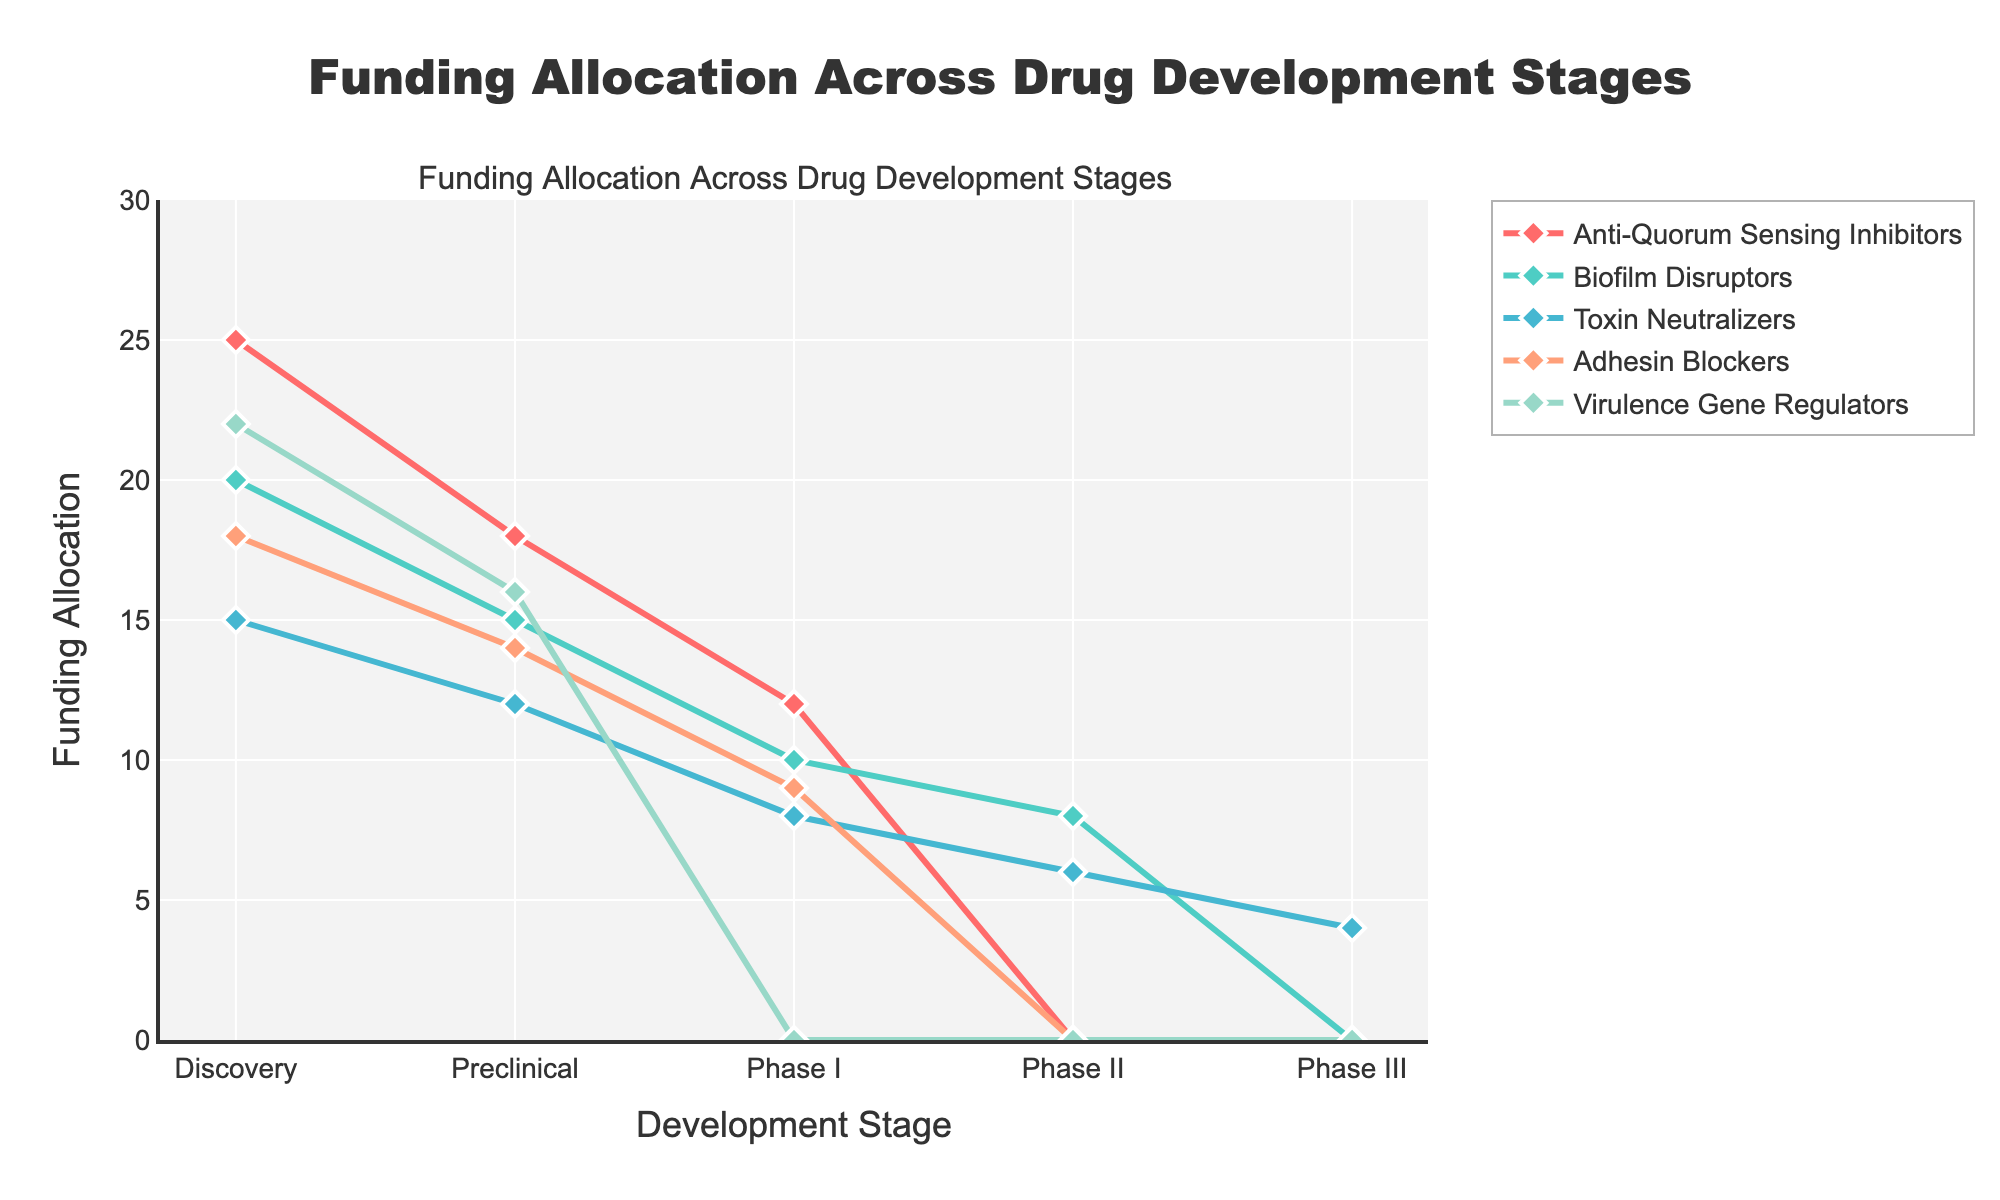What is the title of the figure? The figure's title is prominently displayed at the top center and reads "Funding Allocation Across Drug Development Stages".
Answer: Funding Allocation Across Drug Development Stages Which therapy receives funding in all five stages of drug development? By examining the figure, "Toxin Neutralizers" is the only therapy with a non-zero value across all five stages (Discovery, Preclinical, Phase I, Phase II, and Phase III).
Answer: Toxin Neutralizers At which stage does the "Adhesin Blockers" therapy receive its highest funding? Looking at the "Adhesin Blockers" line, the highest point is at the Discovery stage.
Answer: Discovery How much funding is allocated to "Biofilm Disruptors" at Phase II? The value on the "Biofilm Disruptors" line at the Phase II stage is 8.
Answer: 8 Which therapy has the lowest funding at the Discovery stage? By comparing the values for the Discovery stage, "Toxin Neutralizers" has the lowest funding amount, which is 15.
Answer: Toxin Neutralizers Compare the funding for "Anti-Quorum Sensing Inhibitors" and "Virulence Gene Regulators" at the Preclinical stage. Which one has more funding and by how much? "Anti-Quorum Sensing Inhibitors" has 18 units of funding, while "Virulence Gene Regulators" has 16 units at the Preclinical stage. The difference is 2 units.
Answer: Anti-Quorum Sensing Inhibitors by 2 units What is the sum of the funding for "Anti-Quorum Sensing Inhibitors" across all stages? Adding up the funding values for "Anti-Quorum Sensing Inhibitors" (25 + 18 + 12 + 0 + 0) results in a total of 55.
Answer: 55 Which therapies receive no funding past the Preclinical stage? The lines for "Anti-Quorum Sensing Inhibitors", "Adhesin Blockers", and "Virulence Gene Regulators" all drop to 0 after the Preclinical stage, indicating no funding past this point.
Answer: Anti-Quorum Sensing Inhibitors, Adhesin Blockers, Virulence Gene Regulators On average, how much funding is allocated to "Biofilm Disruptors" across all stages? Summing the values for "Biofilm Disruptors" (20 + 15 + 10 + 8 + 0) and then dividing by the number of stages (5) results in an average funding of 10.6.
Answer: 10.6 In which stage does the total funding for all therapies combined reach its peak? Calculating the sum for each stage and comparing them, we find that the Discovery stage has the highest total funding (25 + 20 + 15 + 18 + 22 = 100).
Answer: Discovery 